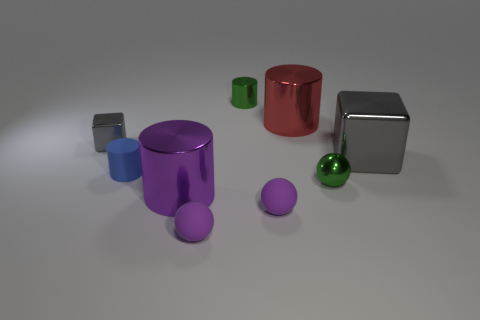Subtract 1 cylinders. How many cylinders are left? 3 Subtract all brown cylinders. Subtract all red spheres. How many cylinders are left? 4 Add 1 small red rubber objects. How many objects exist? 10 Subtract all spheres. How many objects are left? 6 Add 4 balls. How many balls exist? 7 Subtract 0 blue balls. How many objects are left? 9 Subtract all big gray balls. Subtract all tiny metallic spheres. How many objects are left? 8 Add 4 shiny spheres. How many shiny spheres are left? 5 